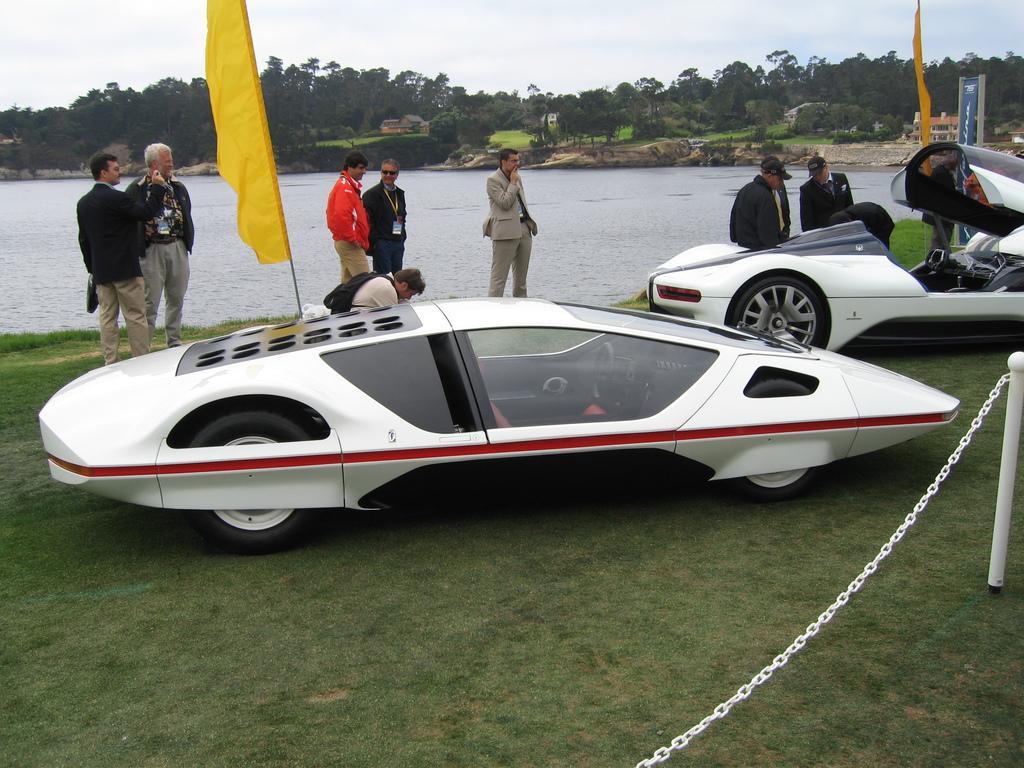Please provide a concise description of this image. In this image, there are some persons wearing clothes and standing beside the lake. There are vehicles in the middle of the image. There is a pole on the right side of the image. There are some trees and sky at the top of the image. 